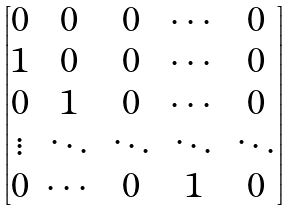<formula> <loc_0><loc_0><loc_500><loc_500>\begin{bmatrix} 0 & 0 & 0 & \cdots & 0 \\ 1 & 0 & 0 & \cdots & 0 \\ 0 & 1 & 0 & \cdots & 0 \\ \vdots & \ddots & \ddots & \ddots & \ddots \\ 0 & \cdots & 0 & 1 & 0 \end{bmatrix}</formula> 